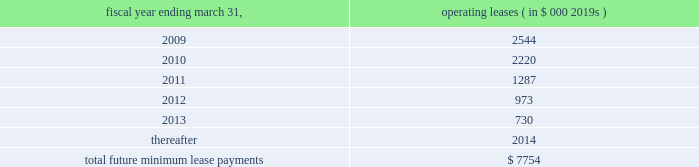Abiomed , inc .
And subsidiaries notes to consolidated financial statements 2014 ( continued ) note 15 .
Commitments and contingencies ( continued ) the company applies the disclosure provisions of fin no .
45 , guarantor 2019s accounting and disclosure requirements for guarantees , including guarantees of indebtedness of others , and interpretation of fasb statements no .
5 , 57 and 107 and rescission of fasb interpretation no .
34 ( fin no .
45 ) to its agreements that contain guarantee or indemnification clauses .
These disclosure provisions expand those required by sfas no .
5 , accounting for contingencies , by requiring that guarantors disclose certain types of guarantees , even if the likelihood of requiring the guarantor 2019s performance is remote .
In addition to product warranties , the following is a description of arrangements in which the company is a guarantor .
Indemnifications 2014in many sales transactions , the company indemnifies customers against possible claims of patent infringement caused by the company 2019s products .
The indemnifications contained within sales contracts usually do not include limits on the claims .
The company has never incurred any material costs to defend lawsuits or settle patent infringement claims related to sales transactions .
Under the provisions of fin no .
45 , intellectual property indemnifications require disclosure only .
The company enters into agreements with other companies in the ordinary course of business , typically with underwriters , contractors , clinical sites and customers that include indemnification provisions .
Under these provisions the company generally indemnifies and holds harmless the indemnified party for losses suffered or incurred by the indemnified party as a result of its activities .
These indemnification provisions generally survive termination of the underlying agreement .
The maximum potential amount of future payments the company could be required to make under these indemnification provisions is unlimited .
Abiomed has never incurred any material costs to defend lawsuits or settle claims related to these indemnification agreements .
As a result , the estimated fair value of these agreements is minimal .
Accordingly , the company has no liabilities recorded for these agreements as of march 31 , 2008 .
Clinical study agreements 2014in the company 2019s clinical study agreements , abiomed has agreed to indemnify the participating institutions against losses incurred by them for claims related to any personal injury of subjects taking part in the study to the extent they relate to uses of the company 2019s devices in accordance with the clinical study agreement , the protocol for the device and abiomed 2019s instructions .
The indemnification provisions contained within the company 2019s clinical study agreements do not generally include limits on the claims .
The company has never incurred any material costs related to the indemnification provisions contained in its clinical study agreements .
Facilities leases 2014as of march 31 , 2008 , the company had entered into leases for its facilities , including its primary operating facility in danvers , massachusetts with terms through fiscal 2010 .
The danvers lease may be extended , at the company 2019s option , for two successive additional periods of five years each with monthly rent charges to be determined based on then current fair rental values .
The company 2019s lease for its aachen location expires in december 2012 .
Total rent expense under these leases , included in the accompanying consolidated statements of operations approximated $ 2.2 million , $ 1.6 million , and $ 1.3 million for the fiscal years ended march 31 , 2008 , 2007 and 2006 , respectively .
Future minimum lease payments under all significant non-cancelable operating leases as of march 31 , 2008 are approximately as follows : fiscal year ending march 31 , operating leases ( in $ 000 2019s ) .
Litigation 2014from time-to-time , the company is involved in legal and administrative proceedings and claims of various types .
While any litigation contains an element of uncertainty , management presently believes that the outcome of each such other proceedings or claims which are pending or known to be threatened , or all of them combined , is not expected to have a material adverse effect on the company 2019s financial position , cash flow and results. .
What percent of future minimum lease payments are due currently? 
Rationale: currently is the next 12 months
Computations: (2544 / 7754)
Answer: 0.32809. 